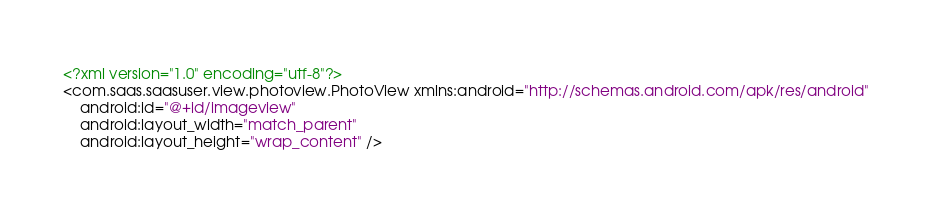<code> <loc_0><loc_0><loc_500><loc_500><_XML_><?xml version="1.0" encoding="utf-8"?>
<com.saas.saasuser.view.photoview.PhotoView xmlns:android="http://schemas.android.com/apk/res/android"
    android:id="@+id/imageview"
    android:layout_width="match_parent"
    android:layout_height="wrap_content" />
</code> 